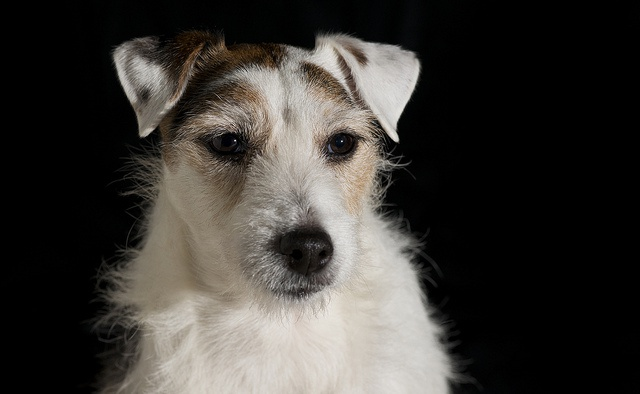Describe the objects in this image and their specific colors. I can see a dog in black, lightgray, darkgray, and gray tones in this image. 